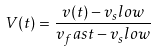<formula> <loc_0><loc_0><loc_500><loc_500>V ( t ) = \frac { v ( t ) - v _ { s } l o w } { v _ { f } a s t - v _ { s } l o w }</formula> 